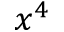Convert formula to latex. <formula><loc_0><loc_0><loc_500><loc_500>x ^ { 4 }</formula> 